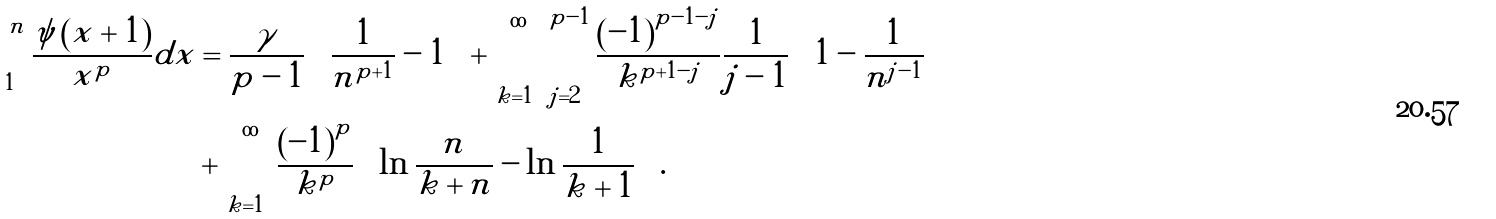Convert formula to latex. <formula><loc_0><loc_0><loc_500><loc_500>\int _ { 1 } ^ { n } \frac { \psi \left ( x + 1 \right ) } { x ^ { p } } d x & = \frac { \gamma } { p - 1 } \left ( \frac { 1 } { n ^ { p + 1 } } - 1 \right ) + \sum _ { k = 1 } ^ { \infty } \sum _ { j = 2 } ^ { p - 1 } \frac { \left ( - 1 \right ) ^ { p - 1 - j } } { k ^ { p + 1 - j } } \frac { 1 } { j - 1 } \left ( 1 - \frac { 1 } { n ^ { j - 1 } } \right ) \\ & + \sum _ { k = 1 } ^ { \infty } \frac { \left ( - 1 \right ) ^ { p } } { k ^ { p } } \left ( \ln \frac { n } { k + n } - \ln \frac { 1 } { k + 1 } \right ) .</formula> 